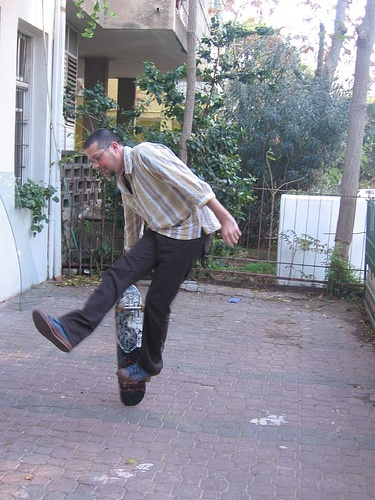Describe the objects in this image and their specific colors. I can see people in lightgray, black, gray, darkgray, and lavender tones, skateboard in lightgray, black, gray, and darkgray tones, and potted plant in lightgray, teal, gray, and darkgray tones in this image. 